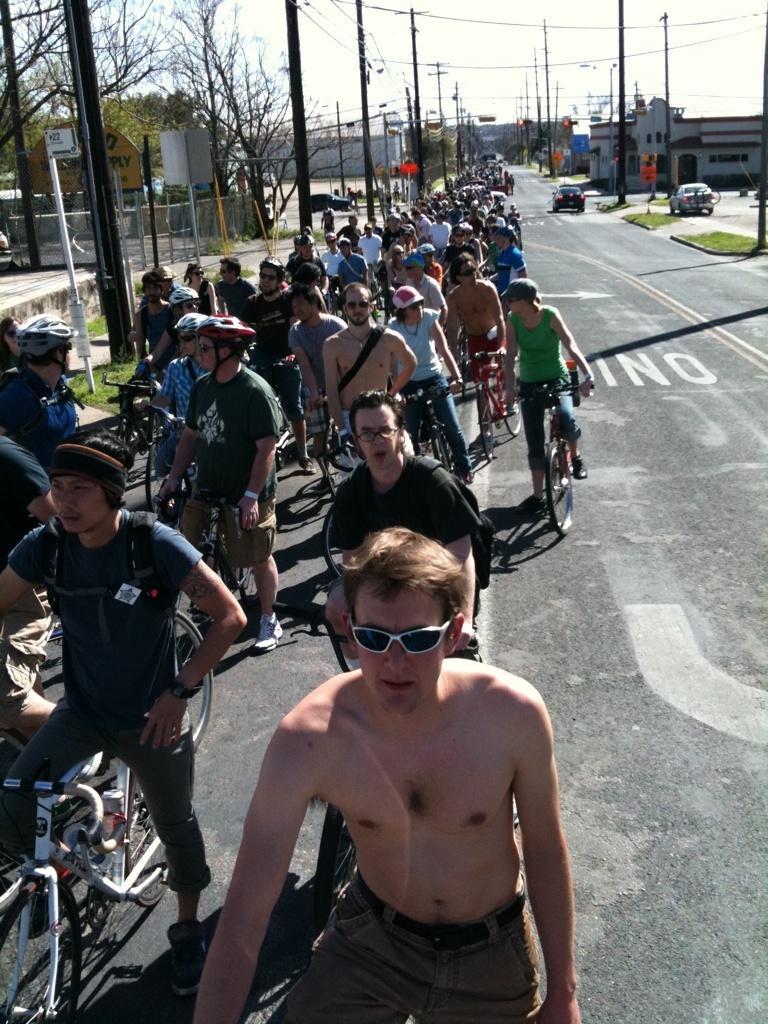Describe this image in one or two sentences. There are many people standing holding cycles. They are wearing goggles and helmets and standing on roads. In the background there are cars, buildings, street lights, poles, trees. 